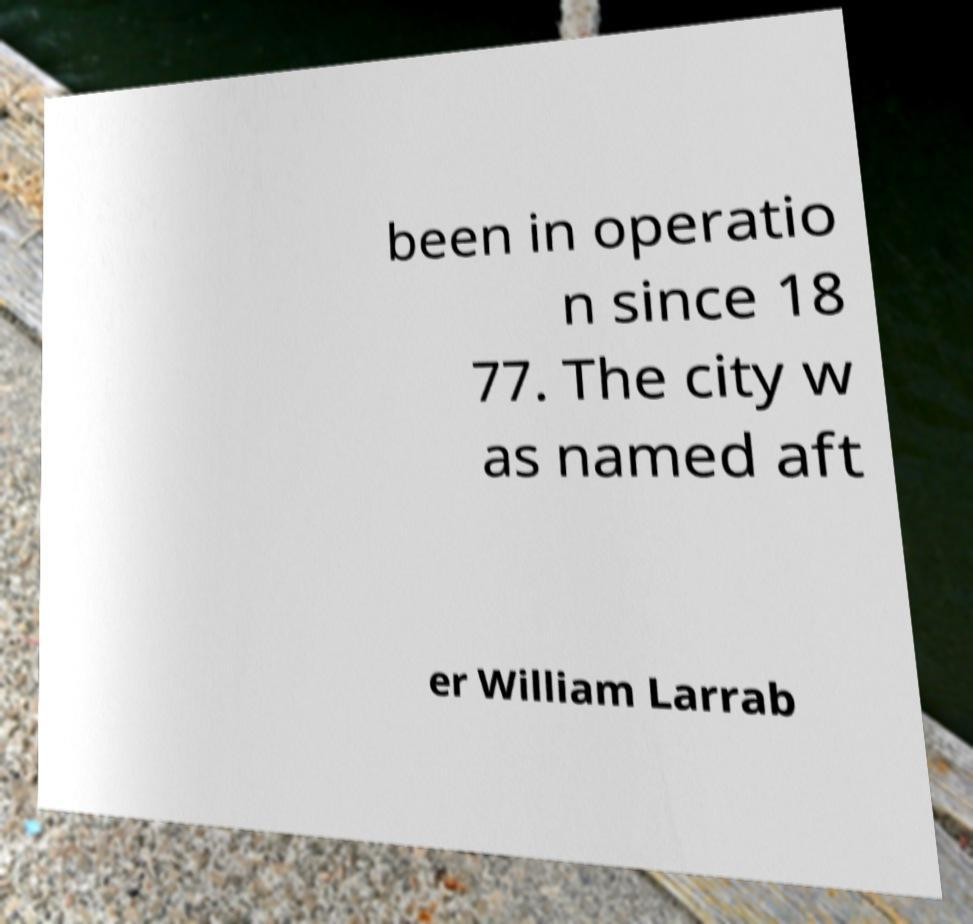Can you read and provide the text displayed in the image?This photo seems to have some interesting text. Can you extract and type it out for me? been in operatio n since 18 77. The city w as named aft er William Larrab 